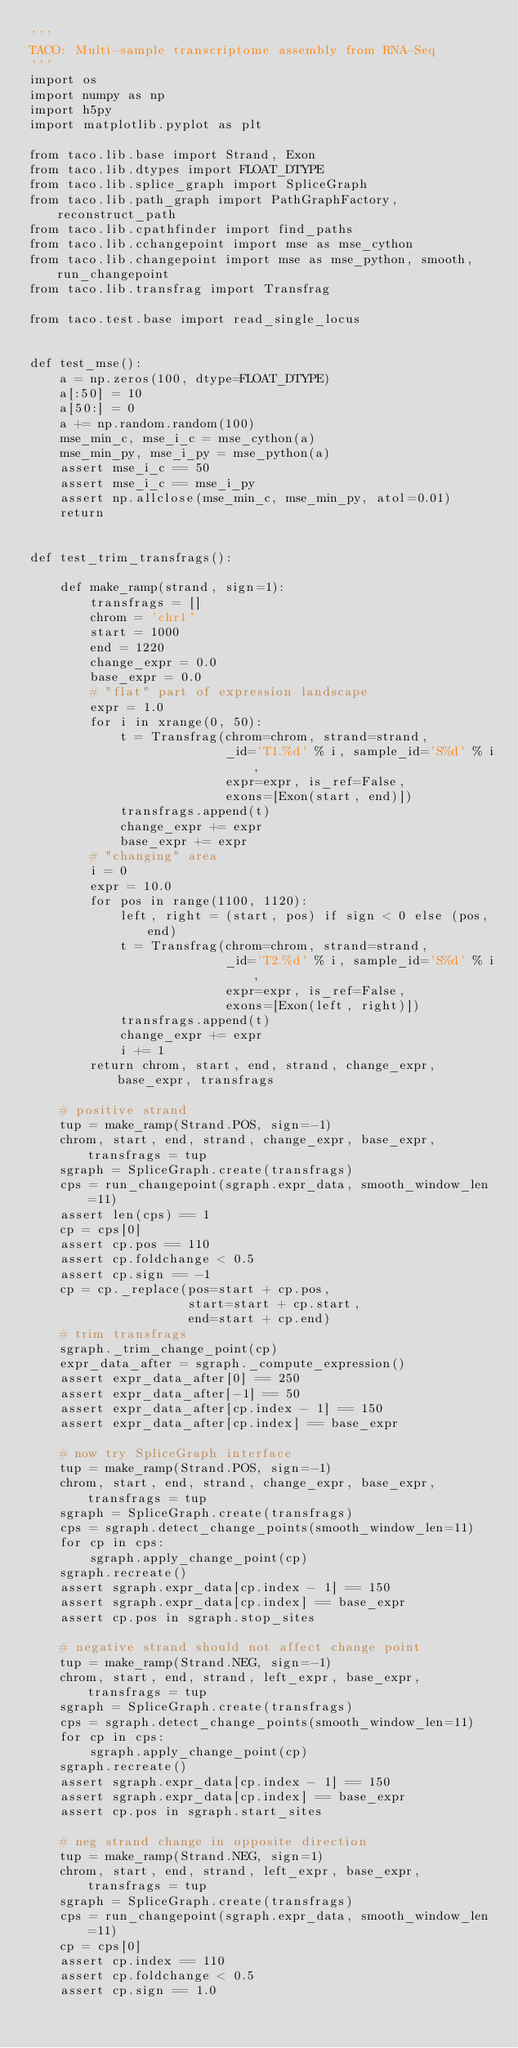<code> <loc_0><loc_0><loc_500><loc_500><_Python_>'''
TACO: Multi-sample transcriptome assembly from RNA-Seq
'''
import os
import numpy as np
import h5py
import matplotlib.pyplot as plt

from taco.lib.base import Strand, Exon
from taco.lib.dtypes import FLOAT_DTYPE
from taco.lib.splice_graph import SpliceGraph
from taco.lib.path_graph import PathGraphFactory, reconstruct_path
from taco.lib.cpathfinder import find_paths
from taco.lib.cchangepoint import mse as mse_cython
from taco.lib.changepoint import mse as mse_python, smooth, run_changepoint
from taco.lib.transfrag import Transfrag

from taco.test.base import read_single_locus


def test_mse():
    a = np.zeros(100, dtype=FLOAT_DTYPE)
    a[:50] = 10
    a[50:] = 0
    a += np.random.random(100)
    mse_min_c, mse_i_c = mse_cython(a)
    mse_min_py, mse_i_py = mse_python(a)
    assert mse_i_c == 50
    assert mse_i_c == mse_i_py
    assert np.allclose(mse_min_c, mse_min_py, atol=0.01)
    return


def test_trim_transfrags():

    def make_ramp(strand, sign=1):
        transfrags = []
        chrom = 'chr1'
        start = 1000
        end = 1220
        change_expr = 0.0
        base_expr = 0.0
        # "flat" part of expression landscape
        expr = 1.0
        for i in xrange(0, 50):
            t = Transfrag(chrom=chrom, strand=strand,
                          _id='T1.%d' % i, sample_id='S%d' % i,
                          expr=expr, is_ref=False,
                          exons=[Exon(start, end)])
            transfrags.append(t)
            change_expr += expr
            base_expr += expr
        # "changing" area
        i = 0
        expr = 10.0
        for pos in range(1100, 1120):
            left, right = (start, pos) if sign < 0 else (pos, end)
            t = Transfrag(chrom=chrom, strand=strand,
                          _id='T2.%d' % i, sample_id='S%d' % i,
                          expr=expr, is_ref=False,
                          exons=[Exon(left, right)])
            transfrags.append(t)
            change_expr += expr
            i += 1
        return chrom, start, end, strand, change_expr, base_expr, transfrags

    # positive strand
    tup = make_ramp(Strand.POS, sign=-1)
    chrom, start, end, strand, change_expr, base_expr, transfrags = tup
    sgraph = SpliceGraph.create(transfrags)
    cps = run_changepoint(sgraph.expr_data, smooth_window_len=11)
    assert len(cps) == 1
    cp = cps[0]
    assert cp.pos == 110
    assert cp.foldchange < 0.5
    assert cp.sign == -1
    cp = cp._replace(pos=start + cp.pos,
                     start=start + cp.start,
                     end=start + cp.end)
    # trim transfrags
    sgraph._trim_change_point(cp)
    expr_data_after = sgraph._compute_expression()
    assert expr_data_after[0] == 250
    assert expr_data_after[-1] == 50
    assert expr_data_after[cp.index - 1] == 150
    assert expr_data_after[cp.index] == base_expr

    # now try SpliceGraph interface
    tup = make_ramp(Strand.POS, sign=-1)
    chrom, start, end, strand, change_expr, base_expr, transfrags = tup
    sgraph = SpliceGraph.create(transfrags)
    cps = sgraph.detect_change_points(smooth_window_len=11)
    for cp in cps:
        sgraph.apply_change_point(cp)
    sgraph.recreate()
    assert sgraph.expr_data[cp.index - 1] == 150
    assert sgraph.expr_data[cp.index] == base_expr
    assert cp.pos in sgraph.stop_sites

    # negative strand should not affect change point
    tup = make_ramp(Strand.NEG, sign=-1)
    chrom, start, end, strand, left_expr, base_expr, transfrags = tup
    sgraph = SpliceGraph.create(transfrags)
    cps = sgraph.detect_change_points(smooth_window_len=11)
    for cp in cps:
        sgraph.apply_change_point(cp)
    sgraph.recreate()
    assert sgraph.expr_data[cp.index - 1] == 150
    assert sgraph.expr_data[cp.index] == base_expr
    assert cp.pos in sgraph.start_sites

    # neg strand change in opposite direction
    tup = make_ramp(Strand.NEG, sign=1)
    chrom, start, end, strand, left_expr, base_expr, transfrags = tup
    sgraph = SpliceGraph.create(transfrags)
    cps = run_changepoint(sgraph.expr_data, smooth_window_len=11)
    cp = cps[0]
    assert cp.index == 110
    assert cp.foldchange < 0.5
    assert cp.sign == 1.0</code> 